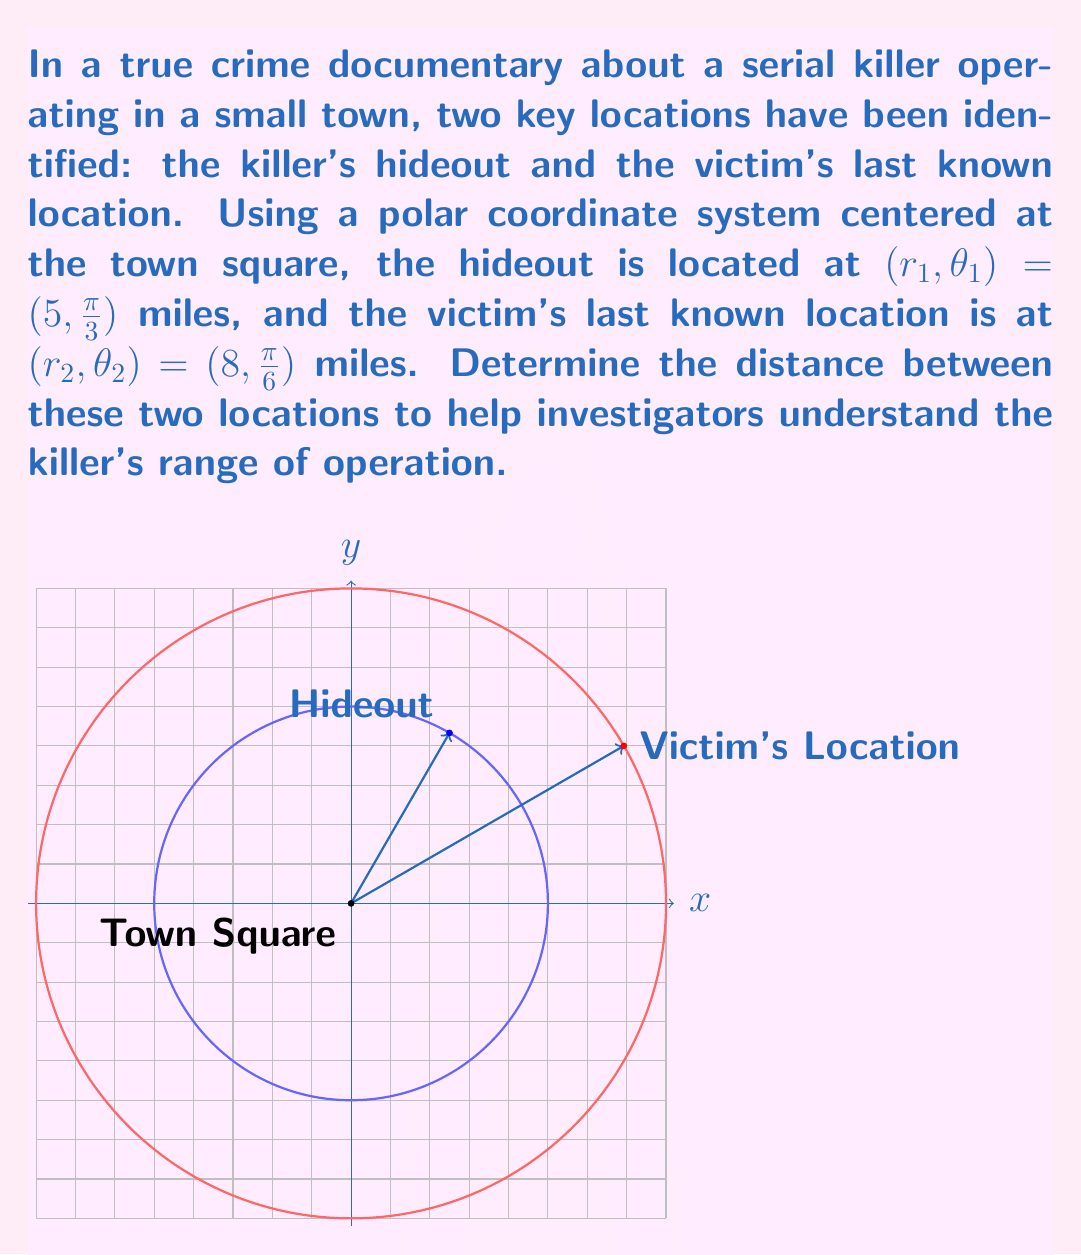Help me with this question. To find the distance between two points in polar coordinates, we can use the polar form of the distance formula:

$$d = \sqrt{r_1^2 + r_2^2 - 2r_1r_2\cos(\theta_2 - \theta_1)}$$

Where:
- $r_1$ and $\theta_1$ are the radius and angle of the first point (hideout)
- $r_2$ and $\theta_2$ are the radius and angle of the second point (victim's location)

Let's substitute the given values:

$r_1 = 5$, $\theta_1 = \frac{\pi}{3}$
$r_2 = 8$, $\theta_2 = \frac{\pi}{6}$

First, calculate $\theta_2 - \theta_1$:
$$\theta_2 - \theta_1 = \frac{\pi}{6} - \frac{\pi}{3} = -\frac{\pi}{6}$$

Now, let's plug these values into the formula:

$$\begin{align}
d &= \sqrt{5^2 + 8^2 - 2(5)(8)\cos(-\frac{\pi}{6})} \\
&= \sqrt{25 + 64 - 80\cos(-\frac{\pi}{6})} \\
&= \sqrt{89 - 80\cos(-\frac{\pi}{6})} \\
&= \sqrt{89 - 80(\frac{\sqrt{3}}{2})} \\
&= \sqrt{89 - 40\sqrt{3}}
\end{align}$$

This is the exact distance between the two locations.
Answer: $\sqrt{89 - 40\sqrt{3}}$ miles 